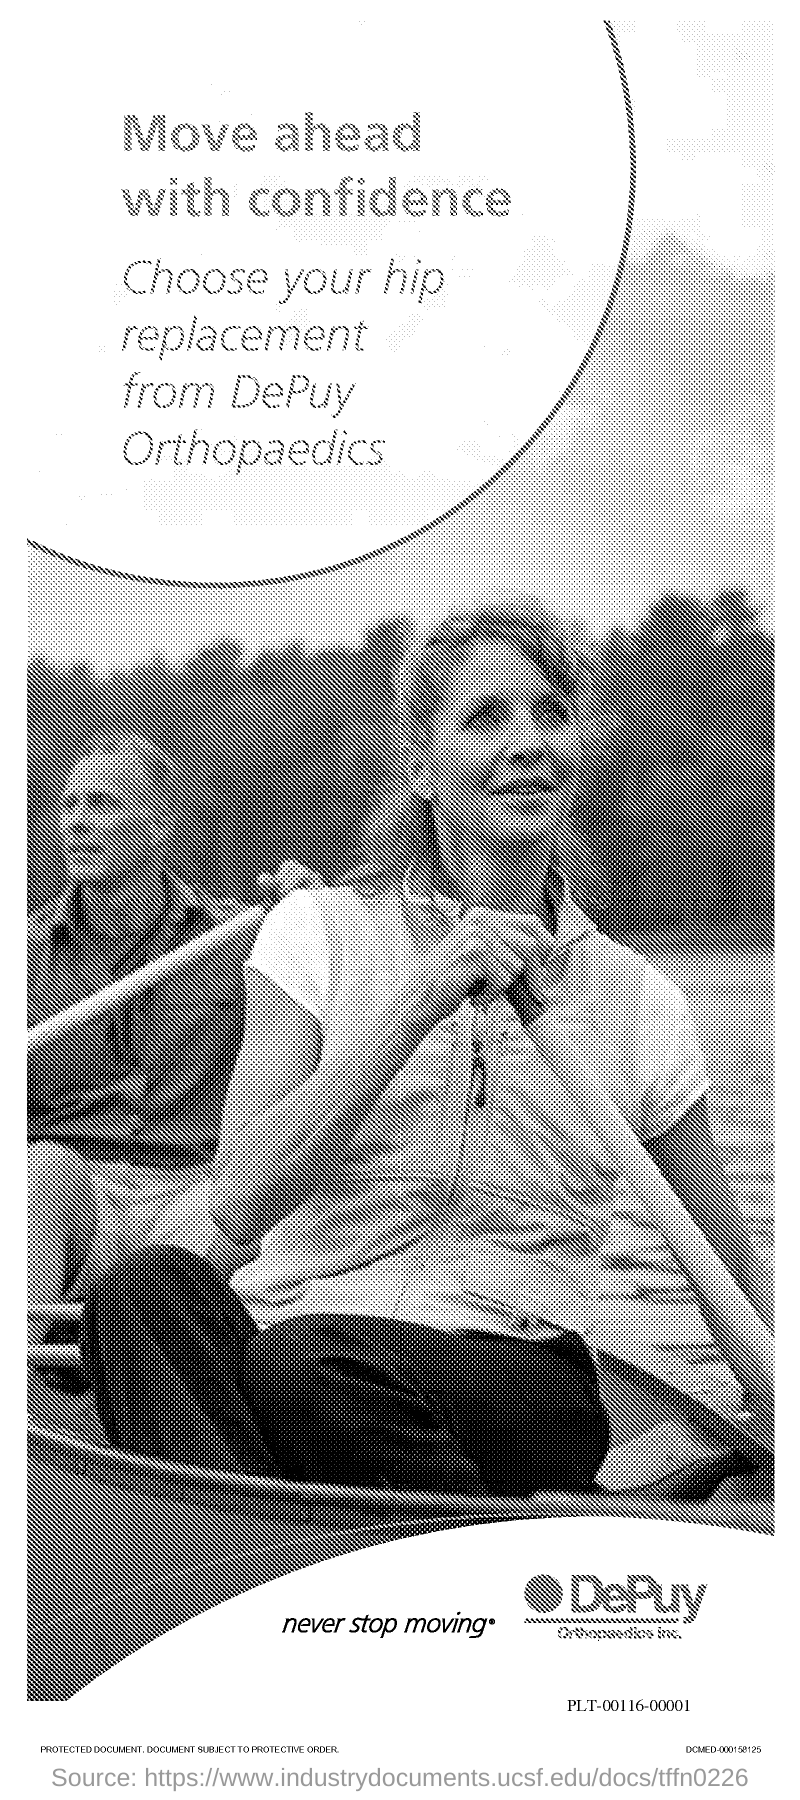What is the first title in the document?
Your response must be concise. Move ahead with confidence. 